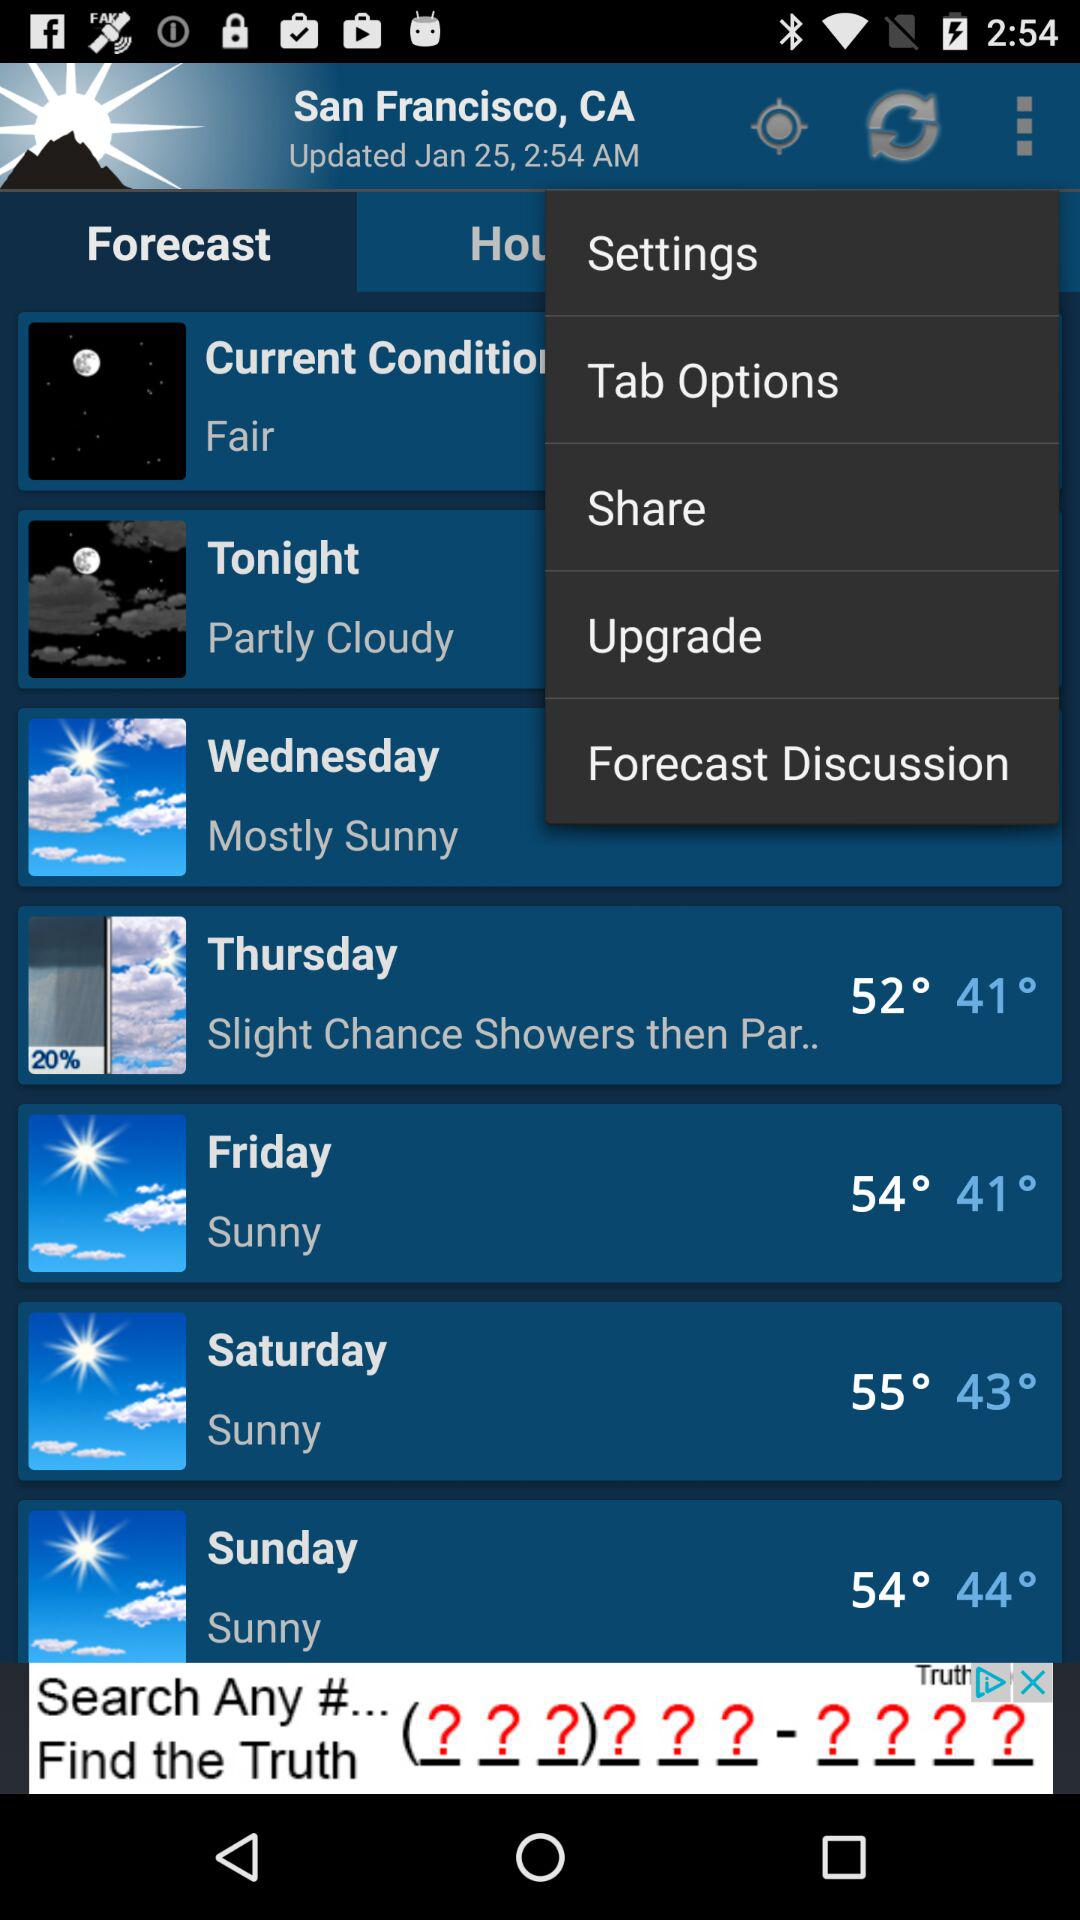When was it last updated? It was last updated on January 25 at 2:54 AM. 